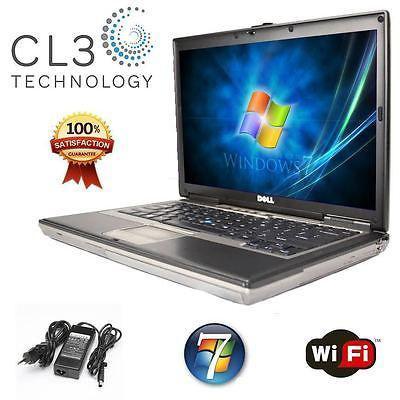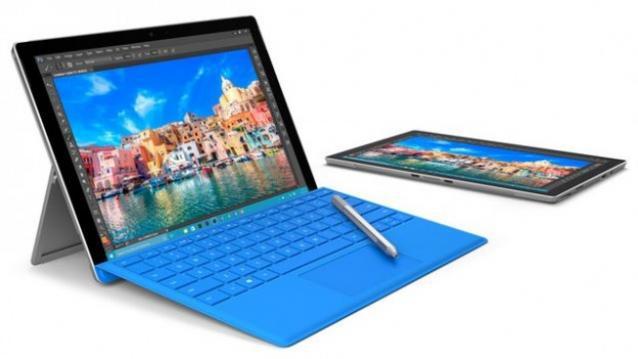The first image is the image on the left, the second image is the image on the right. For the images displayed, is the sentence "The right image shows exactly one laptop with a picture on the back facing outward, and the left image includes at least two laptops that are at least partly open." factually correct? Answer yes or no. No. The first image is the image on the left, the second image is the image on the right. Given the left and right images, does the statement "There are five open laptops with at least two turned away." hold true? Answer yes or no. No. 